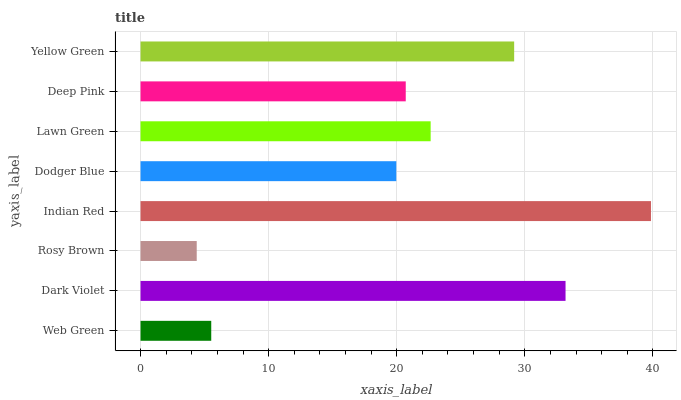Is Rosy Brown the minimum?
Answer yes or no. Yes. Is Indian Red the maximum?
Answer yes or no. Yes. Is Dark Violet the minimum?
Answer yes or no. No. Is Dark Violet the maximum?
Answer yes or no. No. Is Dark Violet greater than Web Green?
Answer yes or no. Yes. Is Web Green less than Dark Violet?
Answer yes or no. Yes. Is Web Green greater than Dark Violet?
Answer yes or no. No. Is Dark Violet less than Web Green?
Answer yes or no. No. Is Lawn Green the high median?
Answer yes or no. Yes. Is Deep Pink the low median?
Answer yes or no. Yes. Is Dark Violet the high median?
Answer yes or no. No. Is Lawn Green the low median?
Answer yes or no. No. 